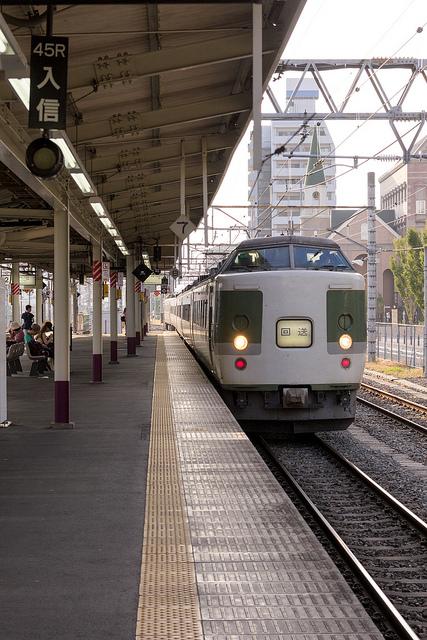What number is the train passing?
Answer briefly. 45. What is the English alphabet letter on the black sign to the left?
Be succinct. R. What color is the train?
Answer briefly. Gray. 